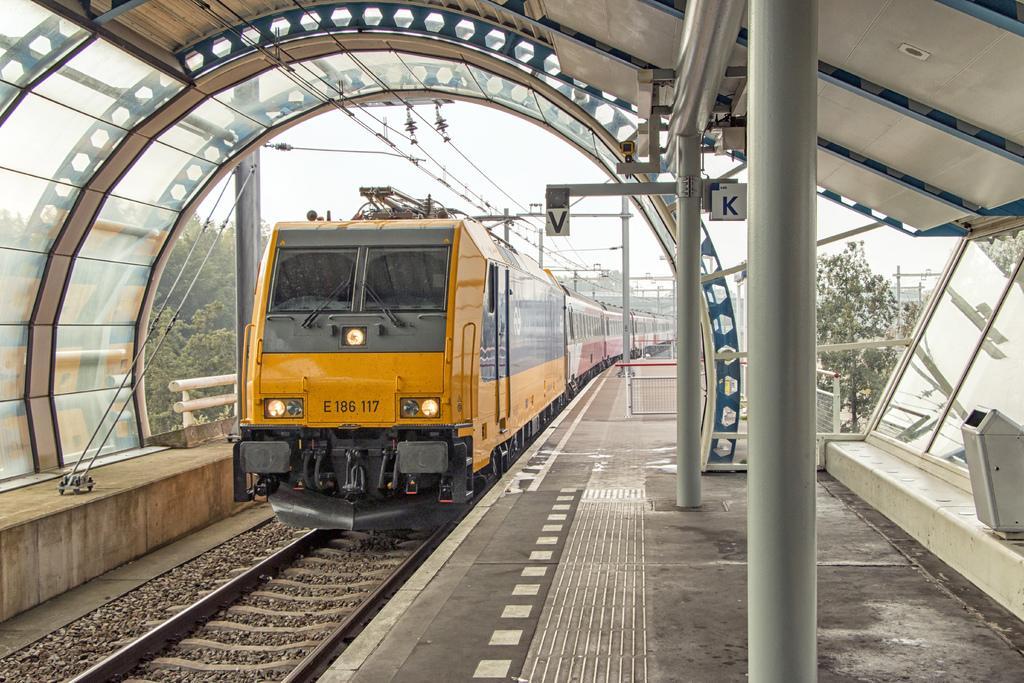Please provide a concise description of this image. In this picture I can see there is a train here and there is a track here and in the backdrop I can see there is a electric pole with some cables. 